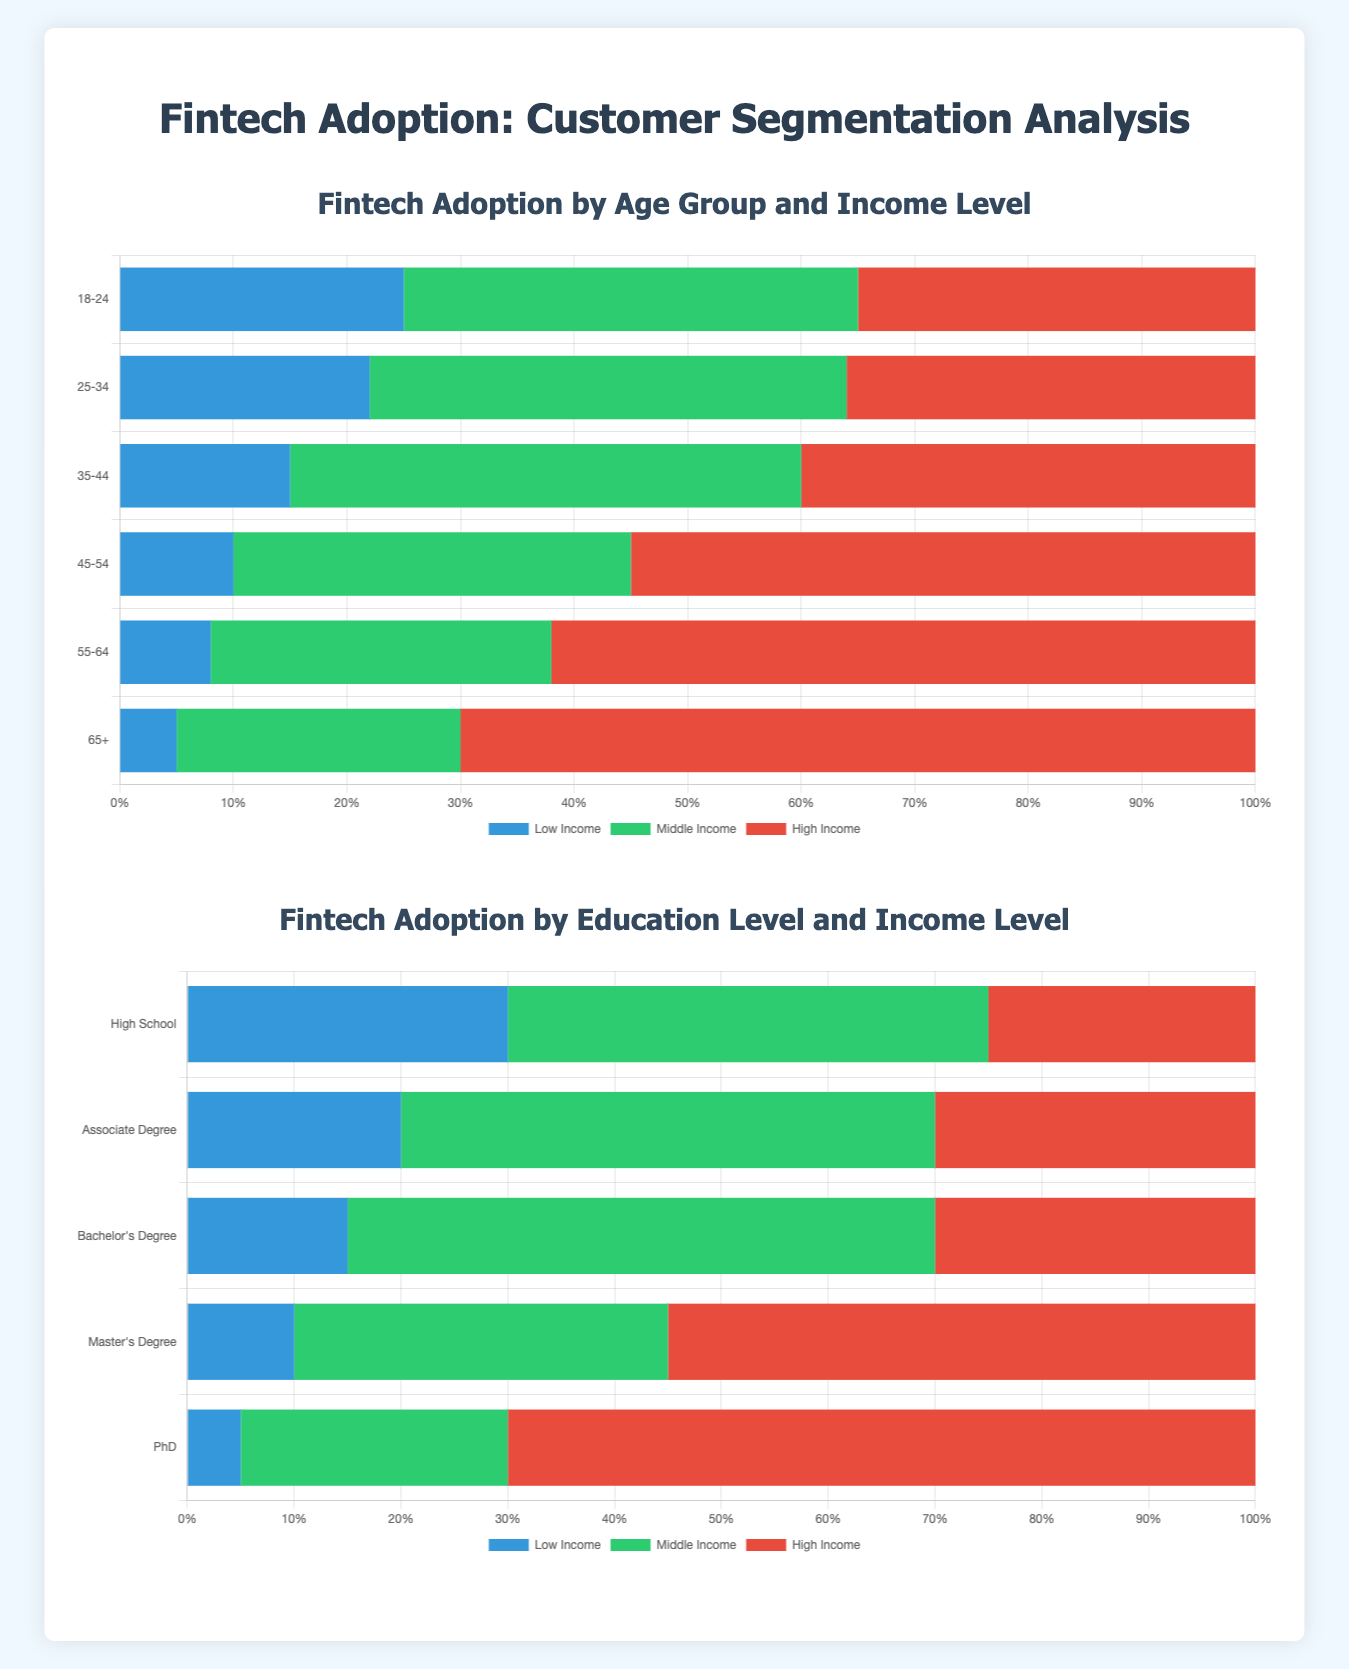What age group has the highest percentage of high-income fintech adopters? According to the chart, the age group 65+ has the highest percentage of high-income fintech adopters with 70%.
Answer: 65+ What is the sum of middle-income fintech adopters for age groups 18-24 and 25-34? The percentage of middle-income fintech adopters for the age groups 18-24 and 25-34 are 40% and 42% respectively. Summing these values gives 40 + 42 = 82%.
Answer: 82% Which education level has the least percentage of low-income fintech adopters? The education level with the least percentage of low-income fintech adopters is PhD, with 5% as shown in the chart.
Answer: PhD For the age group 55-64, how much higher is the high-income fintech adoption compared to the low-income adoption? The high-income fintech adoption for the age group 55-64 is 62% and the low-income fintech adoption is 8%. The difference is 62 - 8 = 54%.
Answer: 54% Compare the percentage of high-income adopters between master's degree holders and bachelor’s degree holders. For master’s degree holders, the percentage of high-income adopters is 55%, while for bachelor’s degree holders it is 30%. Therefore, master’s degree holders have a higher percentage of high-income adopters by 55 - 30 = 25%.
Answer: 25% Which age group has an equal percentage of middle-income and high-income adopters? The age group 35-44 has an equal percentage of middle-income and high-income adopters, both at 45% and 40% respectively, which are close.
Answer: 35-44 What is the ratio of high-income to low-income fintech adopters for the 45-54 age group? For the 45-54 age group, the percentage of high-income adopters is 55% and low-income adopters is 10%. The ratio is 55/10 = 5.5.
Answer: 5.5 Identify the education level with the highest sum of middle-income and high-income adopters. PhD holders have the highest sum of middle-income and high-income adopters with 25% and 70% respectively, summing to 95%.
Answer: PhD Which age group shows the highest diversity in income levels of fintech adopters? The age group 65+ shows the highest diversity with low-income at 5%, middle-income at 25%, and high-income at 70%, indicating a wide spread among income levels.
Answer: 65+ What is the overall trend of high-income adopters as the age progresses? The chart shows that the percentage of high-income adopters increases as the age group progresses from 18-24 to 65+.
Answer: Increases 